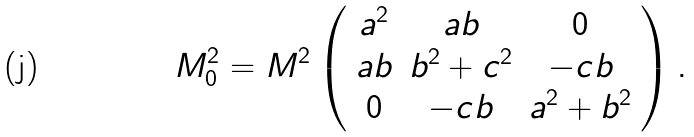<formula> <loc_0><loc_0><loc_500><loc_500>M _ { 0 } ^ { 2 } = M ^ { 2 } \left ( \begin{array} { c c c } a ^ { 2 } & a b & 0 \\ a b & b ^ { 2 } + c ^ { 2 } & - c b \\ 0 & - c b & a ^ { 2 } + b ^ { 2 } \end{array} \right ) .</formula> 